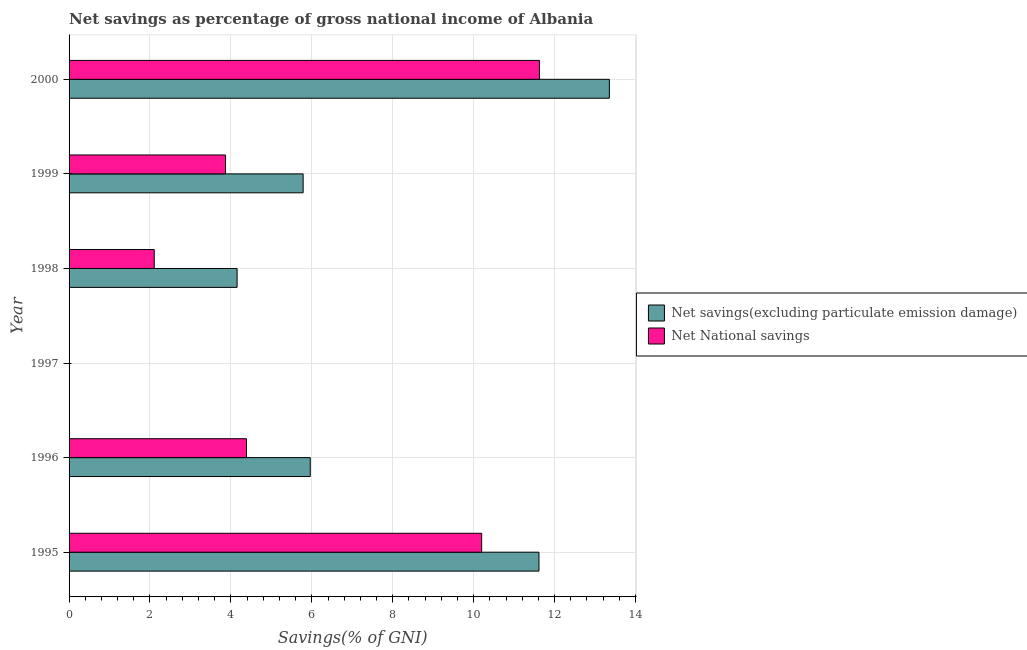How many different coloured bars are there?
Your answer should be compact. 2. Are the number of bars on each tick of the Y-axis equal?
Provide a succinct answer. No. What is the label of the 6th group of bars from the top?
Your response must be concise. 1995. In how many cases, is the number of bars for a given year not equal to the number of legend labels?
Offer a very short reply. 1. What is the net national savings in 1996?
Offer a very short reply. 4.39. Across all years, what is the maximum net savings(excluding particulate emission damage)?
Provide a succinct answer. 13.35. In which year was the net savings(excluding particulate emission damage) maximum?
Provide a succinct answer. 2000. What is the total net savings(excluding particulate emission damage) in the graph?
Your answer should be very brief. 40.87. What is the difference between the net national savings in 1996 and that in 2000?
Give a very brief answer. -7.24. What is the difference between the net savings(excluding particulate emission damage) in 2000 and the net national savings in 1995?
Make the answer very short. 3.16. What is the average net savings(excluding particulate emission damage) per year?
Make the answer very short. 6.81. In the year 1998, what is the difference between the net savings(excluding particulate emission damage) and net national savings?
Your answer should be compact. 2.05. What is the ratio of the net savings(excluding particulate emission damage) in 1995 to that in 1996?
Keep it short and to the point. 1.95. Is the net national savings in 1998 less than that in 1999?
Provide a short and direct response. Yes. Is the difference between the net savings(excluding particulate emission damage) in 1998 and 1999 greater than the difference between the net national savings in 1998 and 1999?
Your answer should be compact. Yes. What is the difference between the highest and the second highest net savings(excluding particulate emission damage)?
Offer a terse response. 1.74. What is the difference between the highest and the lowest net national savings?
Provide a succinct answer. 11.63. In how many years, is the net national savings greater than the average net national savings taken over all years?
Provide a short and direct response. 2. How many bars are there?
Make the answer very short. 10. How many years are there in the graph?
Provide a short and direct response. 6. What is the difference between two consecutive major ticks on the X-axis?
Your answer should be very brief. 2. Are the values on the major ticks of X-axis written in scientific E-notation?
Offer a very short reply. No. Does the graph contain any zero values?
Give a very brief answer. Yes. Does the graph contain grids?
Keep it short and to the point. Yes. Where does the legend appear in the graph?
Your response must be concise. Center right. What is the title of the graph?
Make the answer very short. Net savings as percentage of gross national income of Albania. What is the label or title of the X-axis?
Make the answer very short. Savings(% of GNI). What is the Savings(% of GNI) of Net savings(excluding particulate emission damage) in 1995?
Offer a very short reply. 11.61. What is the Savings(% of GNI) of Net National savings in 1995?
Provide a short and direct response. 10.2. What is the Savings(% of GNI) of Net savings(excluding particulate emission damage) in 1996?
Keep it short and to the point. 5.96. What is the Savings(% of GNI) in Net National savings in 1996?
Provide a short and direct response. 4.39. What is the Savings(% of GNI) of Net National savings in 1997?
Ensure brevity in your answer.  0. What is the Savings(% of GNI) in Net savings(excluding particulate emission damage) in 1998?
Keep it short and to the point. 4.15. What is the Savings(% of GNI) in Net National savings in 1998?
Offer a terse response. 2.1. What is the Savings(% of GNI) in Net savings(excluding particulate emission damage) in 1999?
Offer a very short reply. 5.79. What is the Savings(% of GNI) in Net National savings in 1999?
Provide a short and direct response. 3.87. What is the Savings(% of GNI) in Net savings(excluding particulate emission damage) in 2000?
Provide a succinct answer. 13.35. What is the Savings(% of GNI) of Net National savings in 2000?
Your response must be concise. 11.63. Across all years, what is the maximum Savings(% of GNI) in Net savings(excluding particulate emission damage)?
Your answer should be compact. 13.35. Across all years, what is the maximum Savings(% of GNI) of Net National savings?
Keep it short and to the point. 11.63. Across all years, what is the minimum Savings(% of GNI) in Net savings(excluding particulate emission damage)?
Ensure brevity in your answer.  0. What is the total Savings(% of GNI) in Net savings(excluding particulate emission damage) in the graph?
Ensure brevity in your answer.  40.87. What is the total Savings(% of GNI) in Net National savings in the graph?
Make the answer very short. 32.18. What is the difference between the Savings(% of GNI) of Net savings(excluding particulate emission damage) in 1995 and that in 1996?
Provide a succinct answer. 5.65. What is the difference between the Savings(% of GNI) of Net National savings in 1995 and that in 1996?
Your answer should be compact. 5.81. What is the difference between the Savings(% of GNI) in Net savings(excluding particulate emission damage) in 1995 and that in 1998?
Your answer should be very brief. 7.46. What is the difference between the Savings(% of GNI) of Net National savings in 1995 and that in 1998?
Offer a terse response. 8.09. What is the difference between the Savings(% of GNI) in Net savings(excluding particulate emission damage) in 1995 and that in 1999?
Ensure brevity in your answer.  5.83. What is the difference between the Savings(% of GNI) in Net National savings in 1995 and that in 1999?
Offer a terse response. 6.33. What is the difference between the Savings(% of GNI) in Net savings(excluding particulate emission damage) in 1995 and that in 2000?
Ensure brevity in your answer.  -1.74. What is the difference between the Savings(% of GNI) of Net National savings in 1995 and that in 2000?
Give a very brief answer. -1.43. What is the difference between the Savings(% of GNI) of Net savings(excluding particulate emission damage) in 1996 and that in 1998?
Keep it short and to the point. 1.81. What is the difference between the Savings(% of GNI) in Net National savings in 1996 and that in 1998?
Your answer should be compact. 2.28. What is the difference between the Savings(% of GNI) of Net savings(excluding particulate emission damage) in 1996 and that in 1999?
Ensure brevity in your answer.  0.18. What is the difference between the Savings(% of GNI) of Net National savings in 1996 and that in 1999?
Offer a very short reply. 0.52. What is the difference between the Savings(% of GNI) of Net savings(excluding particulate emission damage) in 1996 and that in 2000?
Keep it short and to the point. -7.39. What is the difference between the Savings(% of GNI) of Net National savings in 1996 and that in 2000?
Your answer should be very brief. -7.24. What is the difference between the Savings(% of GNI) in Net savings(excluding particulate emission damage) in 1998 and that in 1999?
Keep it short and to the point. -1.63. What is the difference between the Savings(% of GNI) of Net National savings in 1998 and that in 1999?
Offer a terse response. -1.76. What is the difference between the Savings(% of GNI) of Net savings(excluding particulate emission damage) in 1998 and that in 2000?
Ensure brevity in your answer.  -9.2. What is the difference between the Savings(% of GNI) in Net National savings in 1998 and that in 2000?
Your response must be concise. -9.52. What is the difference between the Savings(% of GNI) in Net savings(excluding particulate emission damage) in 1999 and that in 2000?
Your response must be concise. -7.57. What is the difference between the Savings(% of GNI) in Net National savings in 1999 and that in 2000?
Your answer should be very brief. -7.76. What is the difference between the Savings(% of GNI) of Net savings(excluding particulate emission damage) in 1995 and the Savings(% of GNI) of Net National savings in 1996?
Your answer should be compact. 7.23. What is the difference between the Savings(% of GNI) of Net savings(excluding particulate emission damage) in 1995 and the Savings(% of GNI) of Net National savings in 1998?
Provide a short and direct response. 9.51. What is the difference between the Savings(% of GNI) of Net savings(excluding particulate emission damage) in 1995 and the Savings(% of GNI) of Net National savings in 1999?
Your response must be concise. 7.75. What is the difference between the Savings(% of GNI) in Net savings(excluding particulate emission damage) in 1995 and the Savings(% of GNI) in Net National savings in 2000?
Your answer should be very brief. -0.01. What is the difference between the Savings(% of GNI) in Net savings(excluding particulate emission damage) in 1996 and the Savings(% of GNI) in Net National savings in 1998?
Ensure brevity in your answer.  3.86. What is the difference between the Savings(% of GNI) of Net savings(excluding particulate emission damage) in 1996 and the Savings(% of GNI) of Net National savings in 1999?
Your answer should be very brief. 2.09. What is the difference between the Savings(% of GNI) in Net savings(excluding particulate emission damage) in 1996 and the Savings(% of GNI) in Net National savings in 2000?
Provide a succinct answer. -5.66. What is the difference between the Savings(% of GNI) in Net savings(excluding particulate emission damage) in 1998 and the Savings(% of GNI) in Net National savings in 1999?
Make the answer very short. 0.29. What is the difference between the Savings(% of GNI) of Net savings(excluding particulate emission damage) in 1998 and the Savings(% of GNI) of Net National savings in 2000?
Your response must be concise. -7.47. What is the difference between the Savings(% of GNI) in Net savings(excluding particulate emission damage) in 1999 and the Savings(% of GNI) in Net National savings in 2000?
Make the answer very short. -5.84. What is the average Savings(% of GNI) in Net savings(excluding particulate emission damage) per year?
Your response must be concise. 6.81. What is the average Savings(% of GNI) of Net National savings per year?
Give a very brief answer. 5.36. In the year 1995, what is the difference between the Savings(% of GNI) of Net savings(excluding particulate emission damage) and Savings(% of GNI) of Net National savings?
Your response must be concise. 1.42. In the year 1996, what is the difference between the Savings(% of GNI) of Net savings(excluding particulate emission damage) and Savings(% of GNI) of Net National savings?
Your answer should be compact. 1.58. In the year 1998, what is the difference between the Savings(% of GNI) in Net savings(excluding particulate emission damage) and Savings(% of GNI) in Net National savings?
Provide a short and direct response. 2.05. In the year 1999, what is the difference between the Savings(% of GNI) of Net savings(excluding particulate emission damage) and Savings(% of GNI) of Net National savings?
Your answer should be compact. 1.92. In the year 2000, what is the difference between the Savings(% of GNI) of Net savings(excluding particulate emission damage) and Savings(% of GNI) of Net National savings?
Provide a short and direct response. 1.73. What is the ratio of the Savings(% of GNI) in Net savings(excluding particulate emission damage) in 1995 to that in 1996?
Give a very brief answer. 1.95. What is the ratio of the Savings(% of GNI) in Net National savings in 1995 to that in 1996?
Provide a short and direct response. 2.33. What is the ratio of the Savings(% of GNI) in Net savings(excluding particulate emission damage) in 1995 to that in 1998?
Your response must be concise. 2.8. What is the ratio of the Savings(% of GNI) of Net National savings in 1995 to that in 1998?
Ensure brevity in your answer.  4.84. What is the ratio of the Savings(% of GNI) in Net savings(excluding particulate emission damage) in 1995 to that in 1999?
Offer a terse response. 2.01. What is the ratio of the Savings(% of GNI) of Net National savings in 1995 to that in 1999?
Your answer should be compact. 2.64. What is the ratio of the Savings(% of GNI) of Net savings(excluding particulate emission damage) in 1995 to that in 2000?
Your answer should be compact. 0.87. What is the ratio of the Savings(% of GNI) in Net National savings in 1995 to that in 2000?
Your answer should be compact. 0.88. What is the ratio of the Savings(% of GNI) of Net savings(excluding particulate emission damage) in 1996 to that in 1998?
Offer a very short reply. 1.44. What is the ratio of the Savings(% of GNI) of Net National savings in 1996 to that in 1998?
Keep it short and to the point. 2.08. What is the ratio of the Savings(% of GNI) of Net savings(excluding particulate emission damage) in 1996 to that in 1999?
Your answer should be compact. 1.03. What is the ratio of the Savings(% of GNI) in Net National savings in 1996 to that in 1999?
Your response must be concise. 1.13. What is the ratio of the Savings(% of GNI) of Net savings(excluding particulate emission damage) in 1996 to that in 2000?
Provide a succinct answer. 0.45. What is the ratio of the Savings(% of GNI) of Net National savings in 1996 to that in 2000?
Your answer should be compact. 0.38. What is the ratio of the Savings(% of GNI) of Net savings(excluding particulate emission damage) in 1998 to that in 1999?
Your answer should be compact. 0.72. What is the ratio of the Savings(% of GNI) of Net National savings in 1998 to that in 1999?
Offer a very short reply. 0.54. What is the ratio of the Savings(% of GNI) in Net savings(excluding particulate emission damage) in 1998 to that in 2000?
Provide a short and direct response. 0.31. What is the ratio of the Savings(% of GNI) of Net National savings in 1998 to that in 2000?
Offer a terse response. 0.18. What is the ratio of the Savings(% of GNI) of Net savings(excluding particulate emission damage) in 1999 to that in 2000?
Your answer should be very brief. 0.43. What is the ratio of the Savings(% of GNI) of Net National savings in 1999 to that in 2000?
Your answer should be compact. 0.33. What is the difference between the highest and the second highest Savings(% of GNI) of Net savings(excluding particulate emission damage)?
Offer a very short reply. 1.74. What is the difference between the highest and the second highest Savings(% of GNI) in Net National savings?
Give a very brief answer. 1.43. What is the difference between the highest and the lowest Savings(% of GNI) in Net savings(excluding particulate emission damage)?
Keep it short and to the point. 13.35. What is the difference between the highest and the lowest Savings(% of GNI) in Net National savings?
Give a very brief answer. 11.63. 